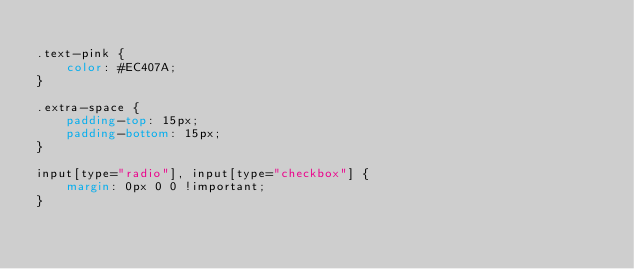Convert code to text. <code><loc_0><loc_0><loc_500><loc_500><_CSS_>
.text-pink {
	color: #EC407A;
}

.extra-space {
	padding-top: 15px;
	padding-bottom: 15px;
}

input[type="radio"], input[type="checkbox"] {
	margin: 0px 0 0 !important;
}</code> 